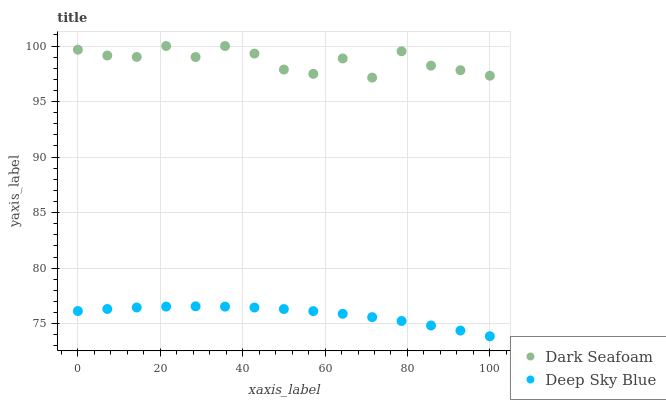Does Deep Sky Blue have the minimum area under the curve?
Answer yes or no. Yes. Does Dark Seafoam have the maximum area under the curve?
Answer yes or no. Yes. Does Deep Sky Blue have the maximum area under the curve?
Answer yes or no. No. Is Deep Sky Blue the smoothest?
Answer yes or no. Yes. Is Dark Seafoam the roughest?
Answer yes or no. Yes. Is Deep Sky Blue the roughest?
Answer yes or no. No. Does Deep Sky Blue have the lowest value?
Answer yes or no. Yes. Does Dark Seafoam have the highest value?
Answer yes or no. Yes. Does Deep Sky Blue have the highest value?
Answer yes or no. No. Is Deep Sky Blue less than Dark Seafoam?
Answer yes or no. Yes. Is Dark Seafoam greater than Deep Sky Blue?
Answer yes or no. Yes. Does Deep Sky Blue intersect Dark Seafoam?
Answer yes or no. No. 